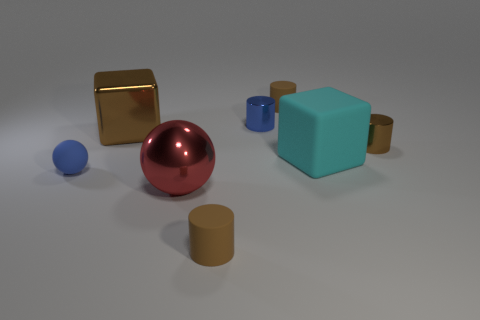Subtract all brown blocks. How many brown cylinders are left? 3 Add 1 small cylinders. How many objects exist? 9 Subtract all spheres. How many objects are left? 6 Add 8 metallic spheres. How many metallic spheres exist? 9 Subtract 0 red cylinders. How many objects are left? 8 Subtract all large objects. Subtract all big red rubber cubes. How many objects are left? 5 Add 7 large brown cubes. How many large brown cubes are left? 8 